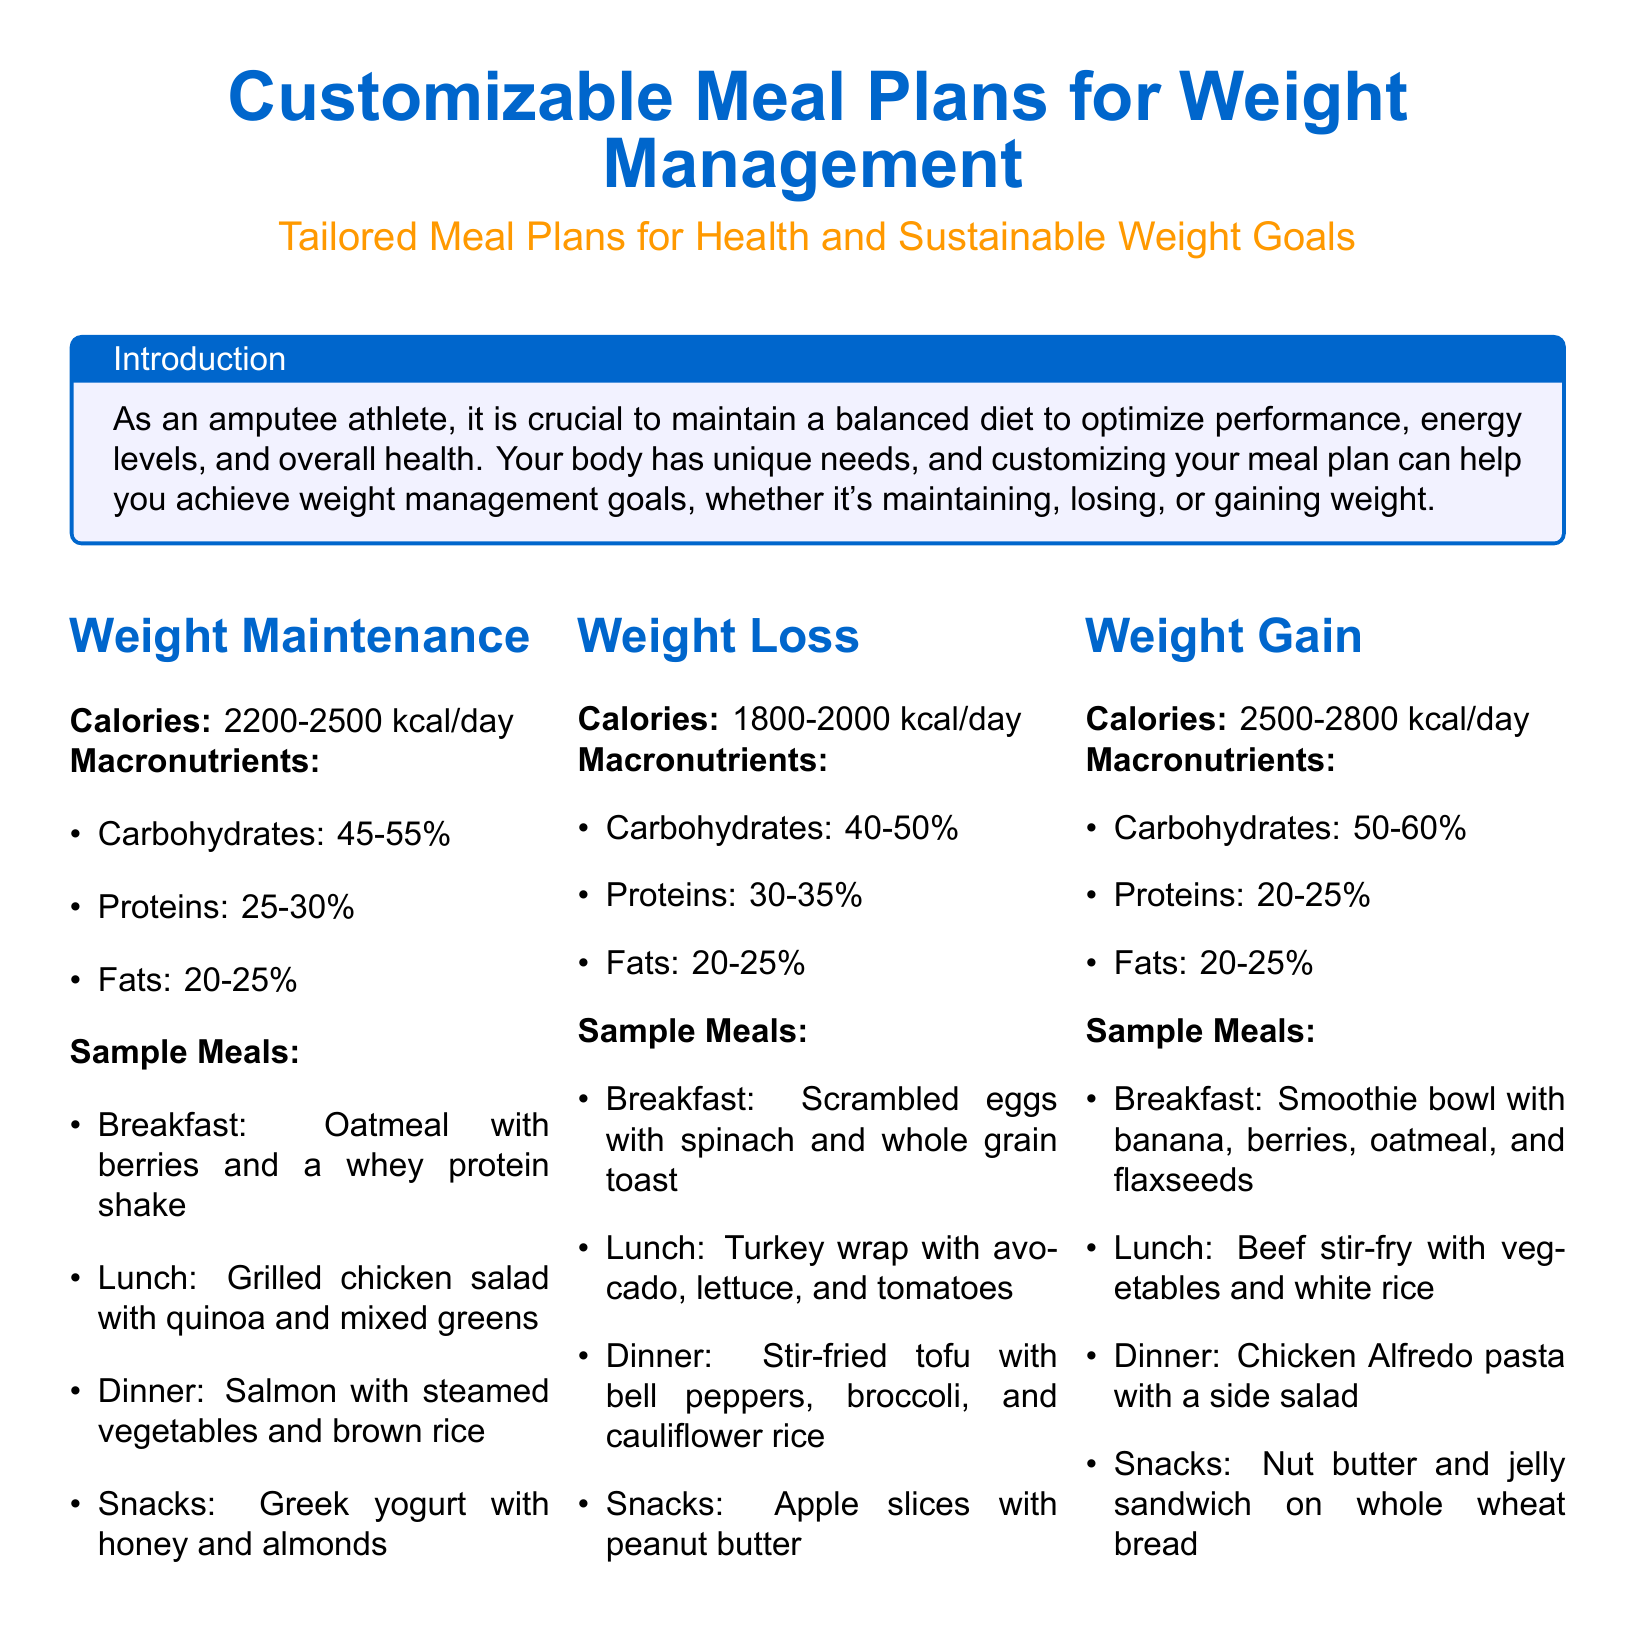What is the calorie range for weight maintenance? The calorie range for weight maintenance is specified in the meal plan as 2200-2500 kcal/day.
Answer: 2200-2500 kcal/day What percentage of fats is recommended for weight loss? The document outlines the macronutrient breakdown for weight loss, which includes 20-25% of fats.
Answer: 20-25% What is a sample breakfast for weight gain? The sample breakfast for weight gain in the meal plan is a smoothie bowl with banana, berries, oatmeal, and flaxseeds.
Answer: Smoothie bowl with banana, berries, oatmeal, and flaxseeds How many calories are recommended for weight loss? The document indicates a calorie range of 1800-2000 kcal/day for weight loss.
Answer: 1800-2000 kcal/day What are two dietary preferences mentioned in the flexible options? The flexible options section lists dietary preferences, including Vegan and Vegetarian.
Answer: Vegan, Vegetarian What is the main focus of customizing a meal plan for an amputee athlete? The introduction emphasizes that customizing a meal plan helps achieve weight management goals tailored for an amputee athlete's unique needs.
Answer: Achieving weight management goals What should be considered as hydration guidelines? The document advises drinking at least 8 cups of water daily as part of hydration guidelines.
Answer: 8 cups of water daily What is a recommendation for supplements? The meal plan suggests considering supplements like Vitamin D and Omega-3 as recommended by a healthcare provider.
Answer: Vitamin D and Omega-3 What is the macronutrient breakdown for weight gain? The macronutrient breakdown for weight gain is listed as 50-60% carbohydrates, 20-25% proteins, and 20-25% fats.
Answer: 50-60% carbohydrates, 20-25% proteins, 20-25% fats 